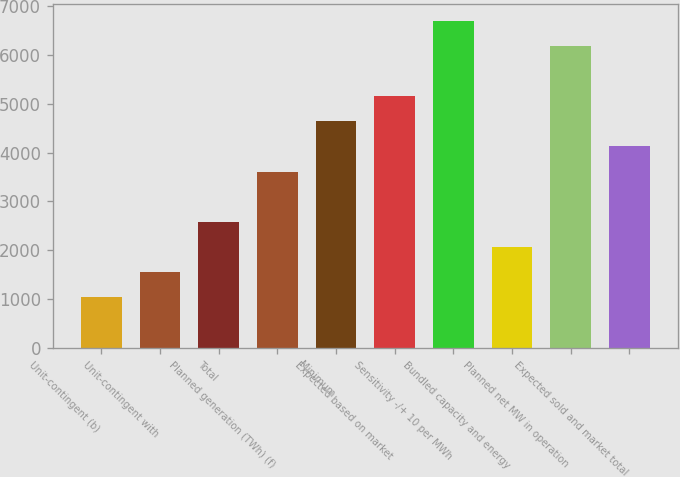<chart> <loc_0><loc_0><loc_500><loc_500><bar_chart><fcel>Unit-contingent (b)<fcel>Unit-contingent with<fcel>Total<fcel>Planned generation (TWh) (f)<fcel>Minimum<fcel>Expected based on market<fcel>Sensitivity -/+ 10 per MWh<fcel>Bundled capacity and energy<fcel>Planned net MW in operation<fcel>Expected sold and market total<nl><fcel>1035.6<fcel>1550.4<fcel>2580<fcel>3609.6<fcel>4639.2<fcel>5154<fcel>6698.4<fcel>2065.2<fcel>6183.6<fcel>4124.4<nl></chart> 